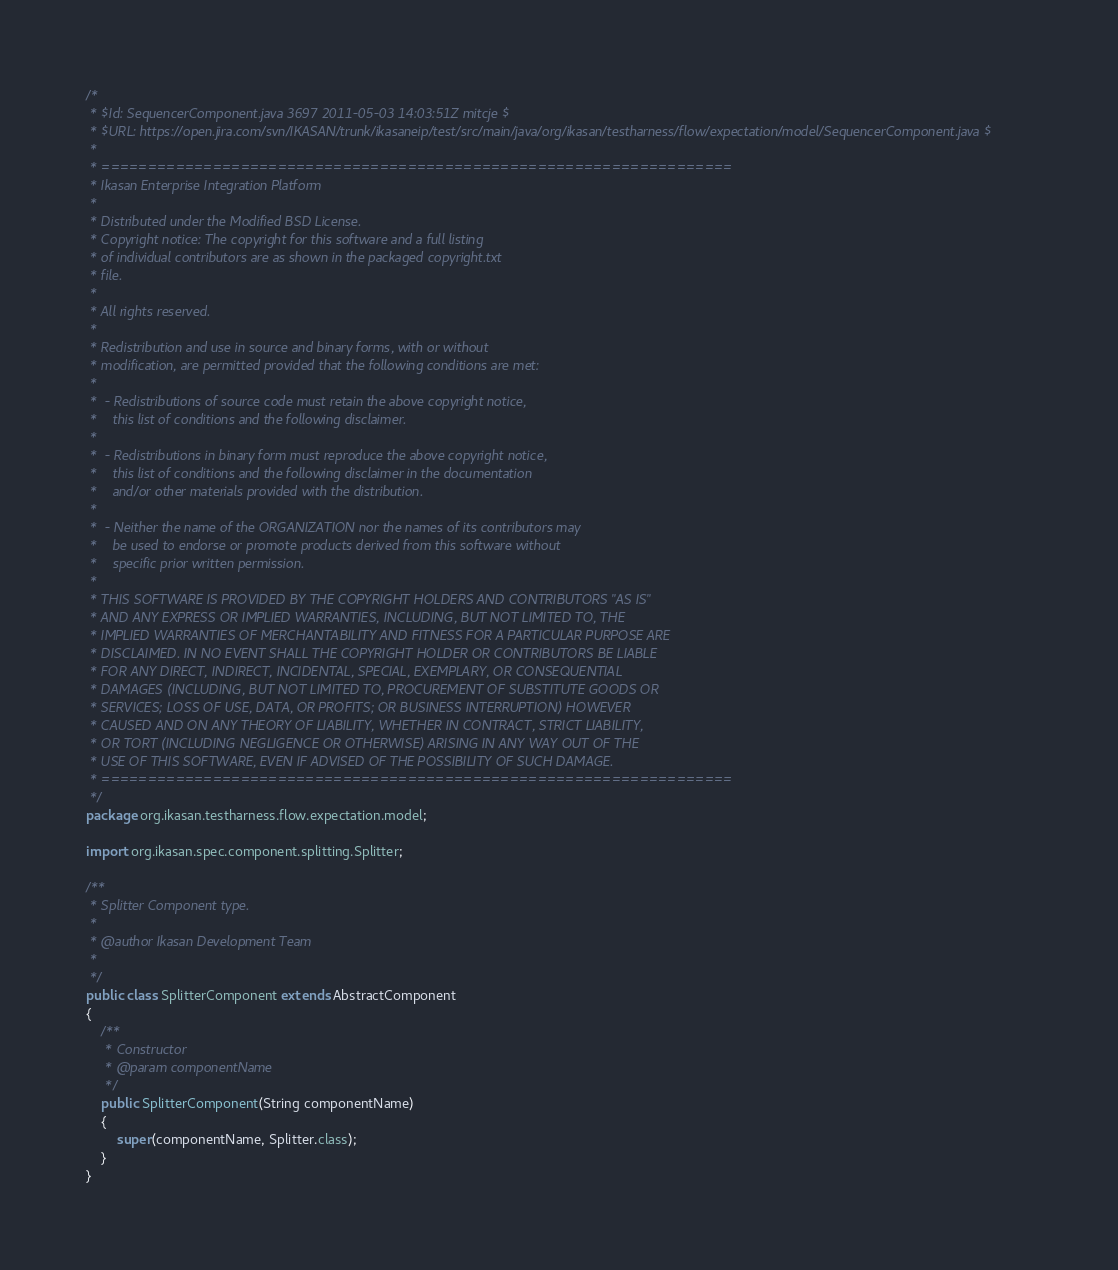<code> <loc_0><loc_0><loc_500><loc_500><_Java_>/*
 * $Id: SequencerComponent.java 3697 2011-05-03 14:03:51Z mitcje $
 * $URL: https://open.jira.com/svn/IKASAN/trunk/ikasaneip/test/src/main/java/org/ikasan/testharness/flow/expectation/model/SequencerComponent.java $
 * 
 * ====================================================================
 * Ikasan Enterprise Integration Platform
 * 
 * Distributed under the Modified BSD License.
 * Copyright notice: The copyright for this software and a full listing 
 * of individual contributors are as shown in the packaged copyright.txt 
 * file. 
 * 
 * All rights reserved.
 *
 * Redistribution and use in source and binary forms, with or without 
 * modification, are permitted provided that the following conditions are met:
 *
 *  - Redistributions of source code must retain the above copyright notice, 
 *    this list of conditions and the following disclaimer.
 *
 *  - Redistributions in binary form must reproduce the above copyright notice, 
 *    this list of conditions and the following disclaimer in the documentation 
 *    and/or other materials provided with the distribution.
 *
 *  - Neither the name of the ORGANIZATION nor the names of its contributors may
 *    be used to endorse or promote products derived from this software without 
 *    specific prior written permission.
 *
 * THIS SOFTWARE IS PROVIDED BY THE COPYRIGHT HOLDERS AND CONTRIBUTORS "AS IS" 
 * AND ANY EXPRESS OR IMPLIED WARRANTIES, INCLUDING, BUT NOT LIMITED TO, THE 
 * IMPLIED WARRANTIES OF MERCHANTABILITY AND FITNESS FOR A PARTICULAR PURPOSE ARE 
 * DISCLAIMED. IN NO EVENT SHALL THE COPYRIGHT HOLDER OR CONTRIBUTORS BE LIABLE 
 * FOR ANY DIRECT, INDIRECT, INCIDENTAL, SPECIAL, EXEMPLARY, OR CONSEQUENTIAL 
 * DAMAGES (INCLUDING, BUT NOT LIMITED TO, PROCUREMENT OF SUBSTITUTE GOODS OR 
 * SERVICES; LOSS OF USE, DATA, OR PROFITS; OR BUSINESS INTERRUPTION) HOWEVER 
 * CAUSED AND ON ANY THEORY OF LIABILITY, WHETHER IN CONTRACT, STRICT LIABILITY,
 * OR TORT (INCLUDING NEGLIGENCE OR OTHERWISE) ARISING IN ANY WAY OUT OF THE 
 * USE OF THIS SOFTWARE, EVEN IF ADVISED OF THE POSSIBILITY OF SUCH DAMAGE.
 * ====================================================================
 */
package org.ikasan.testharness.flow.expectation.model;

import org.ikasan.spec.component.splitting.Splitter;

/**
 * Splitter Component type.
 * 
 * @author Ikasan Development Team
 * 
 */
public class SplitterComponent extends AbstractComponent
{
    /**
     * Constructor
     * @param componentName
     */
    public SplitterComponent(String componentName)
    {
        super(componentName, Splitter.class);
    }
}
</code> 